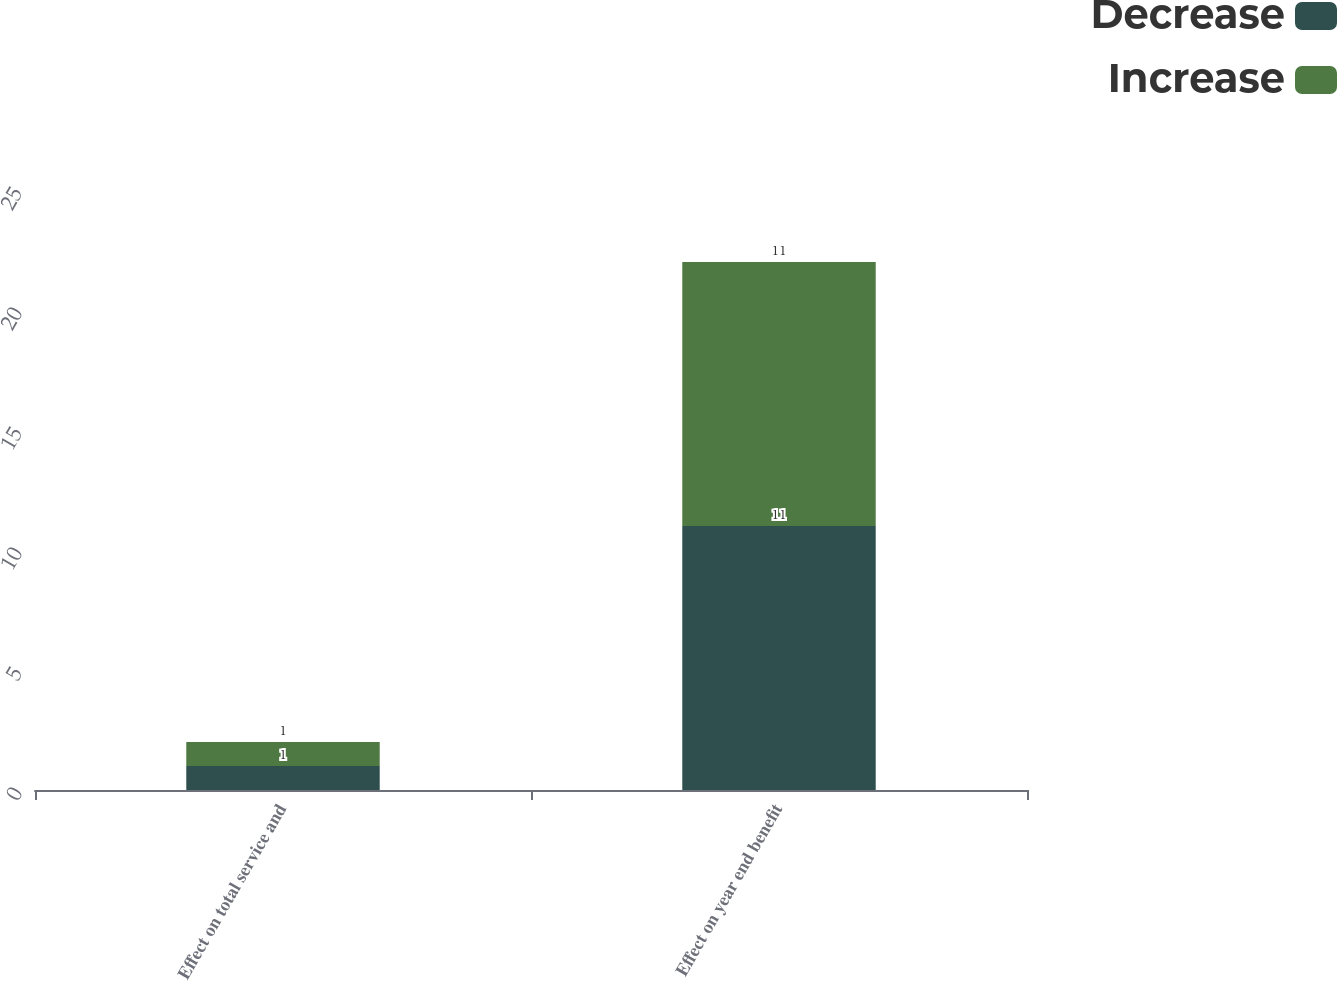Convert chart to OTSL. <chart><loc_0><loc_0><loc_500><loc_500><stacked_bar_chart><ecel><fcel>Effect on total service and<fcel>Effect on year end benefit<nl><fcel>Decrease<fcel>1<fcel>11<nl><fcel>Increase<fcel>1<fcel>11<nl></chart> 